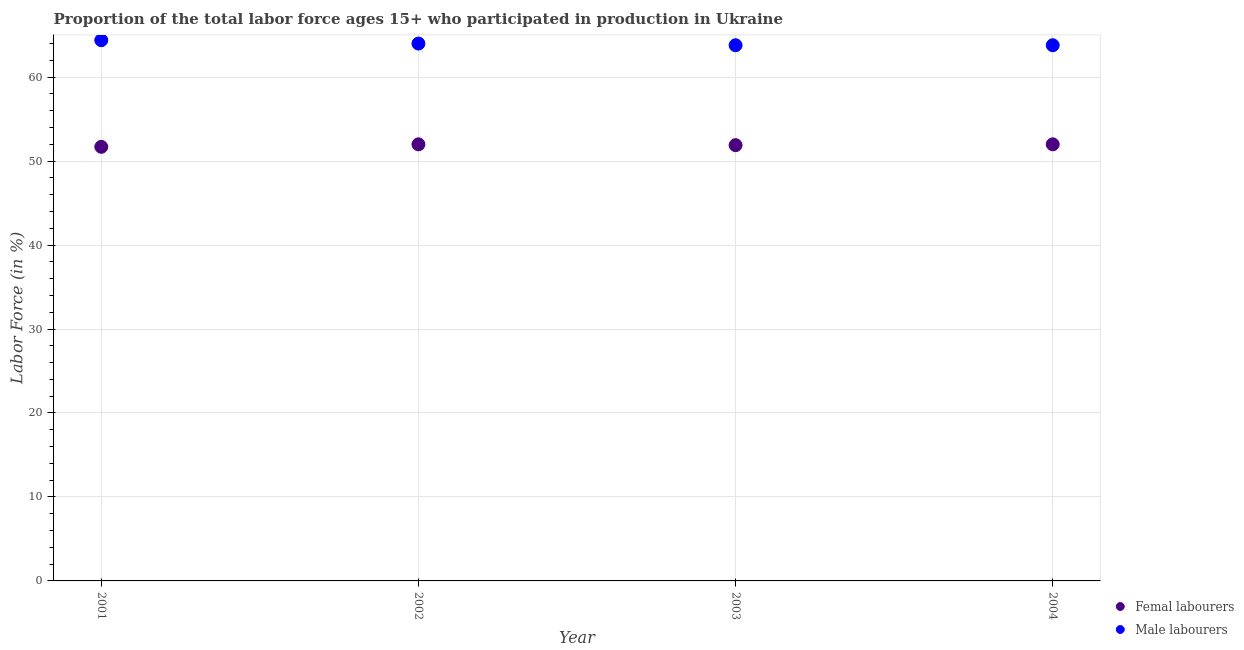How many different coloured dotlines are there?
Provide a succinct answer. 2. Is the number of dotlines equal to the number of legend labels?
Offer a terse response. Yes. What is the percentage of female labor force in 2001?
Make the answer very short. 51.7. Across all years, what is the maximum percentage of female labor force?
Offer a very short reply. 52. Across all years, what is the minimum percentage of female labor force?
Offer a very short reply. 51.7. In which year was the percentage of female labor force maximum?
Keep it short and to the point. 2002. What is the total percentage of male labour force in the graph?
Make the answer very short. 256. What is the difference between the percentage of female labor force in 2002 and that in 2004?
Ensure brevity in your answer.  0. What is the average percentage of female labor force per year?
Your answer should be very brief. 51.9. In the year 2004, what is the difference between the percentage of female labor force and percentage of male labour force?
Provide a short and direct response. -11.8. In how many years, is the percentage of female labor force greater than 30 %?
Offer a very short reply. 4. What is the ratio of the percentage of male labour force in 2002 to that in 2003?
Your answer should be very brief. 1. Is the difference between the percentage of male labour force in 2002 and 2003 greater than the difference between the percentage of female labor force in 2002 and 2003?
Your answer should be compact. Yes. What is the difference between the highest and the second highest percentage of female labor force?
Offer a terse response. 0. What is the difference between the highest and the lowest percentage of male labour force?
Your response must be concise. 0.6. In how many years, is the percentage of male labour force greater than the average percentage of male labour force taken over all years?
Provide a succinct answer. 2. Does the percentage of male labour force monotonically increase over the years?
Offer a very short reply. No. Is the percentage of female labor force strictly greater than the percentage of male labour force over the years?
Offer a very short reply. No. Is the percentage of female labor force strictly less than the percentage of male labour force over the years?
Your response must be concise. Yes. How many dotlines are there?
Offer a terse response. 2. How many years are there in the graph?
Provide a short and direct response. 4. Are the values on the major ticks of Y-axis written in scientific E-notation?
Keep it short and to the point. No. Does the graph contain any zero values?
Your answer should be very brief. No. Does the graph contain grids?
Make the answer very short. Yes. Where does the legend appear in the graph?
Offer a terse response. Bottom right. How are the legend labels stacked?
Give a very brief answer. Vertical. What is the title of the graph?
Your answer should be compact. Proportion of the total labor force ages 15+ who participated in production in Ukraine. What is the label or title of the X-axis?
Ensure brevity in your answer.  Year. What is the Labor Force (in %) in Femal labourers in 2001?
Your response must be concise. 51.7. What is the Labor Force (in %) of Male labourers in 2001?
Your response must be concise. 64.4. What is the Labor Force (in %) in Femal labourers in 2003?
Make the answer very short. 51.9. What is the Labor Force (in %) of Male labourers in 2003?
Make the answer very short. 63.8. What is the Labor Force (in %) of Male labourers in 2004?
Make the answer very short. 63.8. Across all years, what is the maximum Labor Force (in %) in Male labourers?
Ensure brevity in your answer.  64.4. Across all years, what is the minimum Labor Force (in %) of Femal labourers?
Your answer should be very brief. 51.7. Across all years, what is the minimum Labor Force (in %) of Male labourers?
Ensure brevity in your answer.  63.8. What is the total Labor Force (in %) in Femal labourers in the graph?
Provide a short and direct response. 207.6. What is the total Labor Force (in %) in Male labourers in the graph?
Provide a succinct answer. 256. What is the difference between the Labor Force (in %) in Femal labourers in 2001 and that in 2002?
Offer a terse response. -0.3. What is the difference between the Labor Force (in %) of Femal labourers in 2001 and that in 2004?
Offer a terse response. -0.3. What is the difference between the Labor Force (in %) in Femal labourers in 2002 and that in 2003?
Provide a succinct answer. 0.1. What is the difference between the Labor Force (in %) of Femal labourers in 2001 and the Labor Force (in %) of Male labourers in 2002?
Give a very brief answer. -12.3. What is the difference between the Labor Force (in %) in Femal labourers in 2001 and the Labor Force (in %) in Male labourers in 2003?
Your answer should be very brief. -12.1. What is the difference between the Labor Force (in %) of Femal labourers in 2001 and the Labor Force (in %) of Male labourers in 2004?
Your answer should be compact. -12.1. What is the difference between the Labor Force (in %) in Femal labourers in 2002 and the Labor Force (in %) in Male labourers in 2003?
Ensure brevity in your answer.  -11.8. What is the difference between the Labor Force (in %) of Femal labourers in 2002 and the Labor Force (in %) of Male labourers in 2004?
Your answer should be compact. -11.8. What is the difference between the Labor Force (in %) of Femal labourers in 2003 and the Labor Force (in %) of Male labourers in 2004?
Ensure brevity in your answer.  -11.9. What is the average Labor Force (in %) of Femal labourers per year?
Give a very brief answer. 51.9. What is the average Labor Force (in %) in Male labourers per year?
Make the answer very short. 64. In the year 2001, what is the difference between the Labor Force (in %) of Femal labourers and Labor Force (in %) of Male labourers?
Your answer should be compact. -12.7. In the year 2002, what is the difference between the Labor Force (in %) in Femal labourers and Labor Force (in %) in Male labourers?
Provide a short and direct response. -12. In the year 2004, what is the difference between the Labor Force (in %) in Femal labourers and Labor Force (in %) in Male labourers?
Keep it short and to the point. -11.8. What is the ratio of the Labor Force (in %) of Femal labourers in 2001 to that in 2002?
Ensure brevity in your answer.  0.99. What is the ratio of the Labor Force (in %) in Male labourers in 2001 to that in 2003?
Your answer should be very brief. 1.01. What is the ratio of the Labor Force (in %) in Male labourers in 2001 to that in 2004?
Your response must be concise. 1.01. What is the ratio of the Labor Force (in %) of Male labourers in 2002 to that in 2003?
Ensure brevity in your answer.  1. What is the ratio of the Labor Force (in %) in Male labourers in 2002 to that in 2004?
Your answer should be very brief. 1. What is the ratio of the Labor Force (in %) of Male labourers in 2003 to that in 2004?
Your answer should be compact. 1. What is the difference between the highest and the lowest Labor Force (in %) in Femal labourers?
Provide a succinct answer. 0.3. 